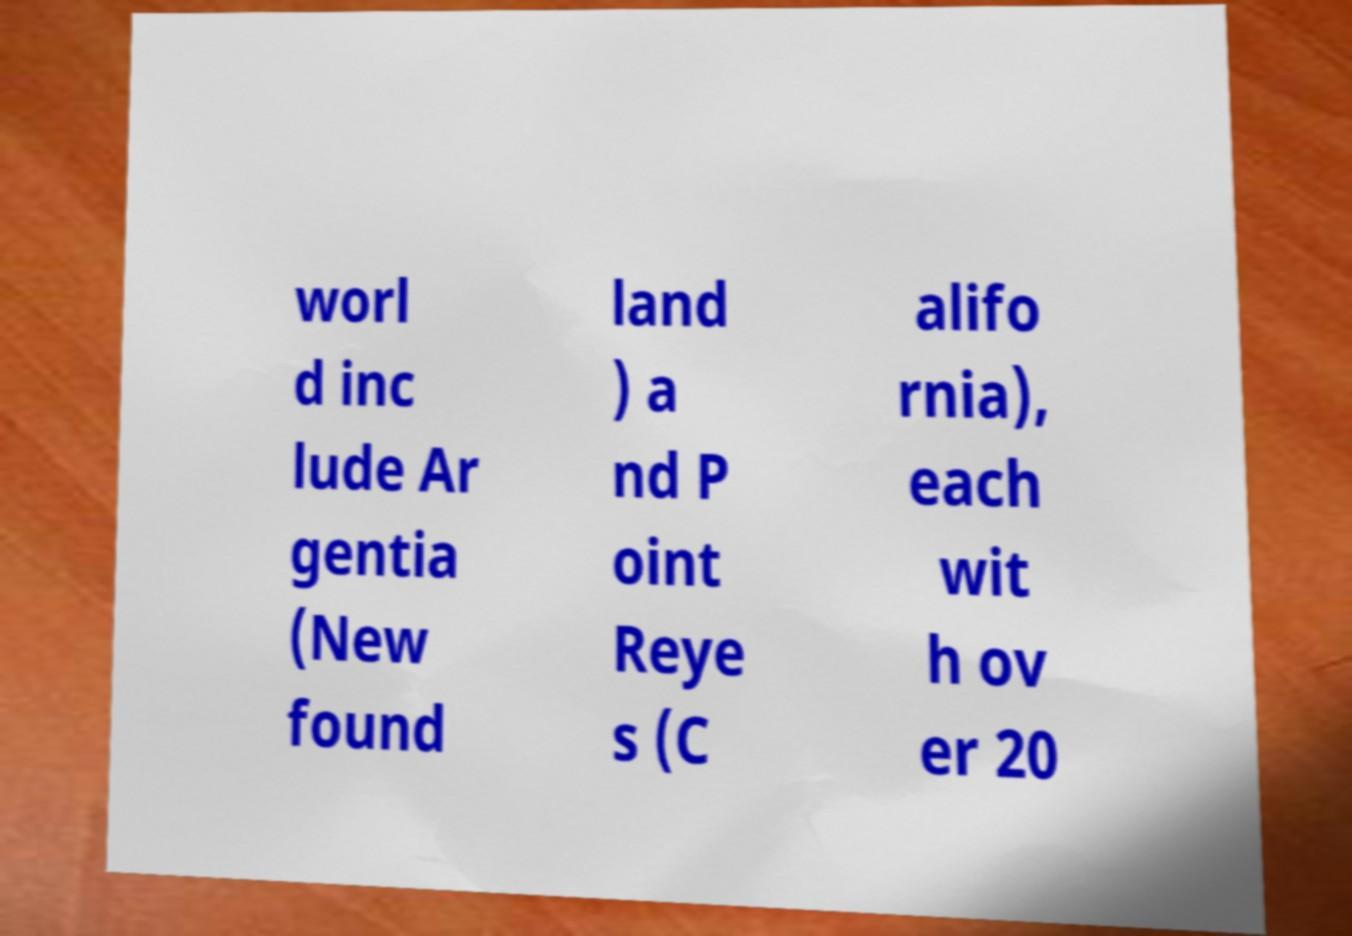For documentation purposes, I need the text within this image transcribed. Could you provide that? worl d inc lude Ar gentia (New found land ) a nd P oint Reye s (C alifo rnia), each wit h ov er 20 